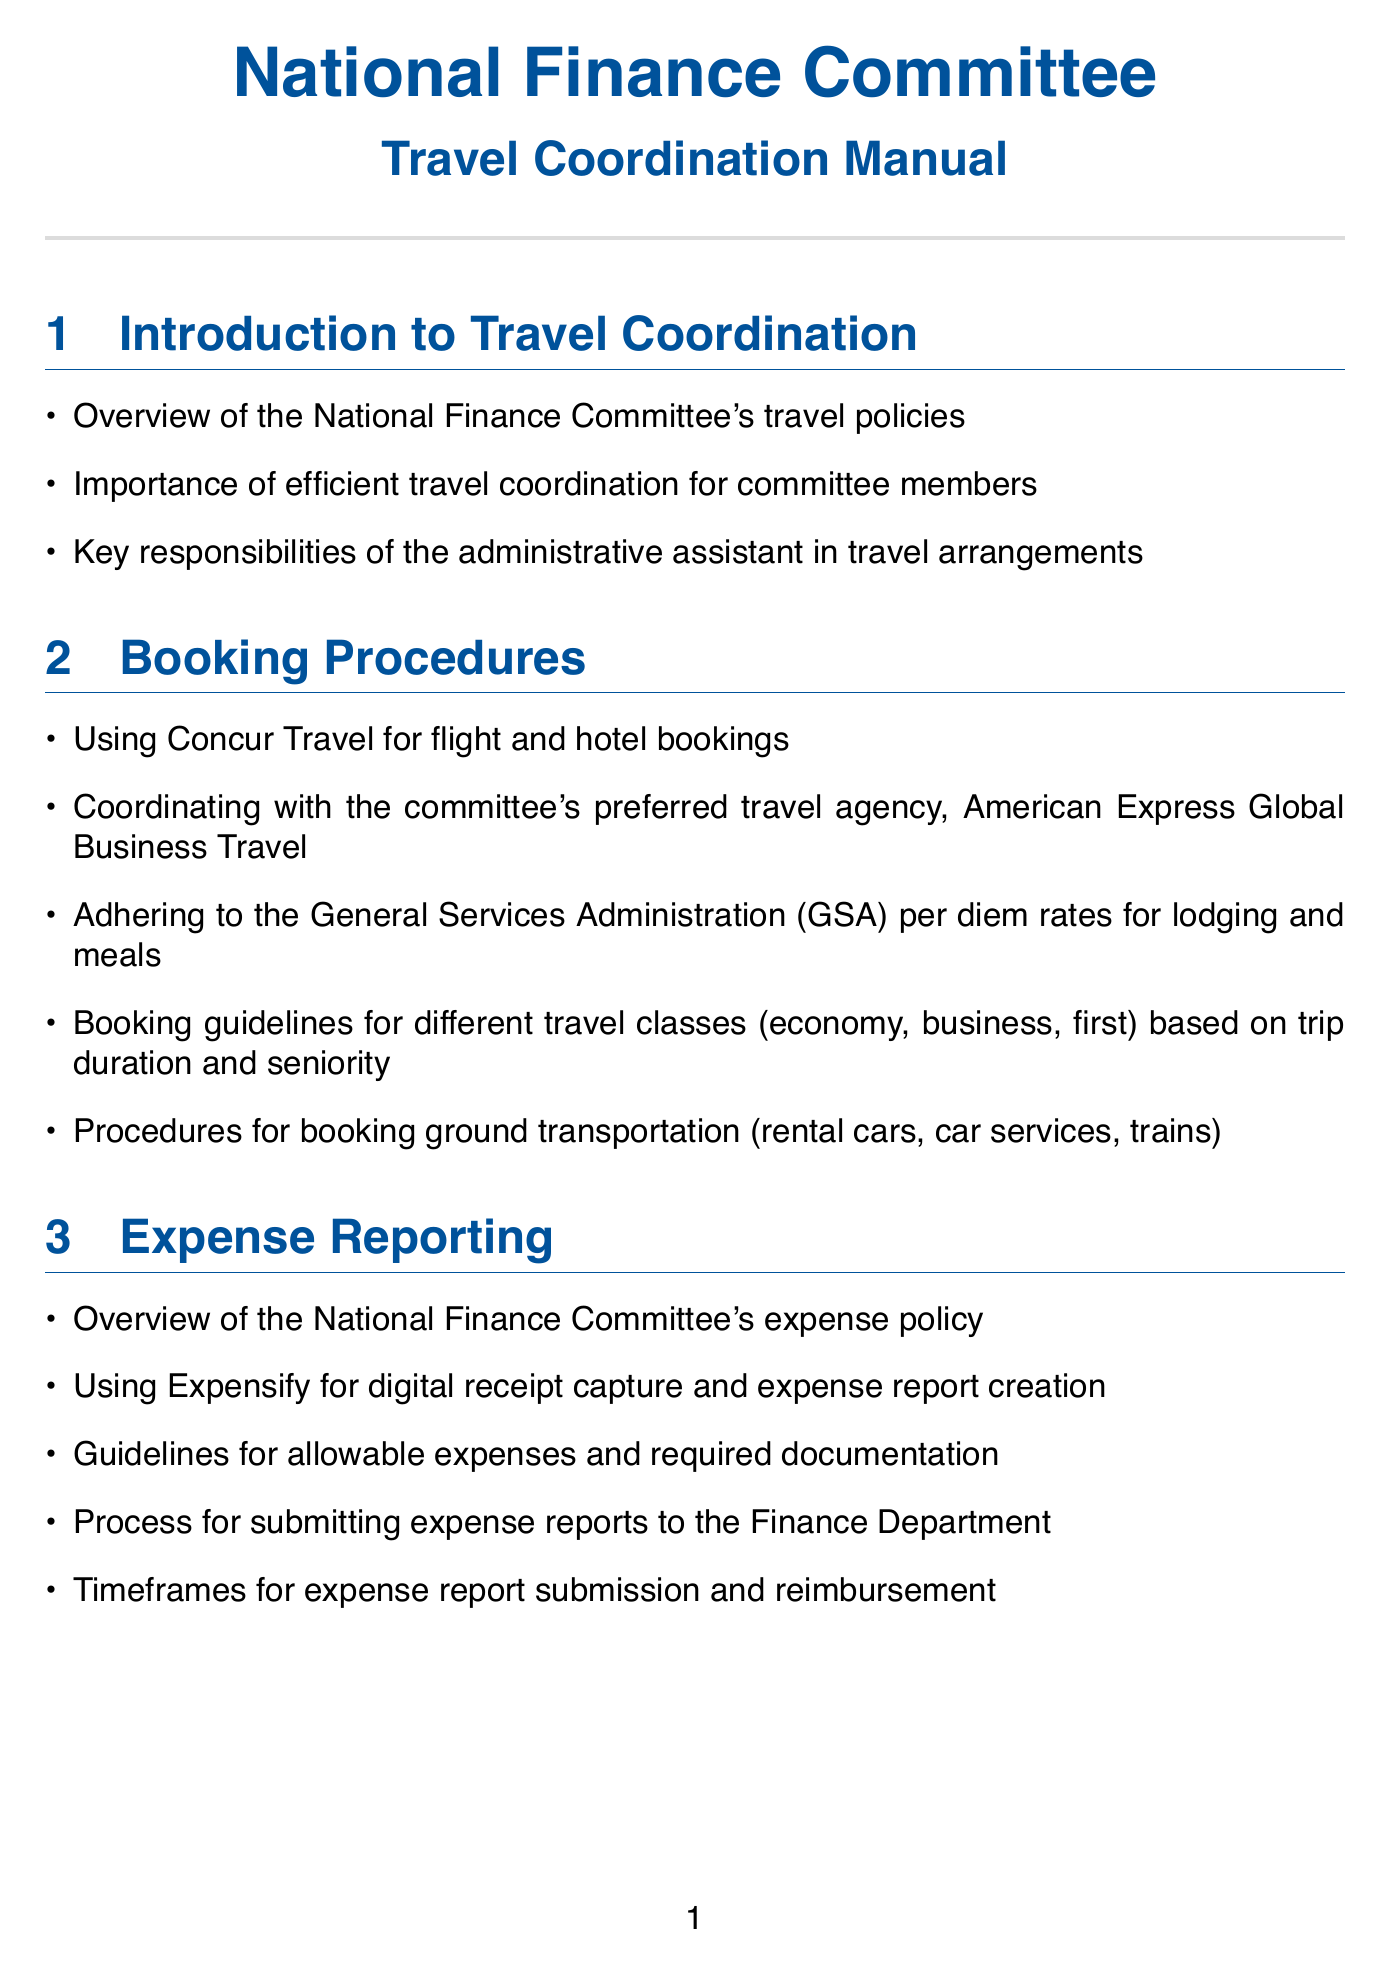What is the title of the manual? The title of the manual is stated prominently at the top of the document, identifying it as a travel coordination manual for the committee.
Answer: Travel Coordination Manual Which travel agency is preferred for bookings? The document specifies that the committee coordinates with a particular travel agency, stating its name directly in the booking procedures section.
Answer: American Express Global Business Travel What tool is used for expense report creation? The expense reporting section of the document mentions a specific software used for digital receipt capture and report creation.
Answer: Expensify What type of communication is arranged for international trips? The manual outlines a specific provider for mobile communication when international travel is coordinated, found in the security considerations section.
Answer: Verizon Global Enterprise List one guideline for booking ground transportation. The document includes a bullet point within the booking procedures discussing the method for arranging ground transportation for committee members.
Answer: Rental cars What is required when booking secure accommodations for domestic trips? The document emphasizes a specific program mentioned in relation to secure bookings for high-profile committee members under domestic security considerations.
Answer: Marriott's BGRC What is one of the roles of the administrative assistant in travel arrangements? The introduction section of the document highlights key responsibilities that fall to the administrative assistant regarding travel coordination for committee members.
Answer: Key responsibilities Which company provides travel insurance for the committee? The travel insurance and emergency procedures section explicitly names the insurance company that covers the committee's travel policy.
Answer: AIG Business Travel What is one method of implementing communication in travel coordination? The technology and tools section describes a specific platform that can be used to facilitate real-time updates during travel planning and arrangements.
Answer: Slack channels 